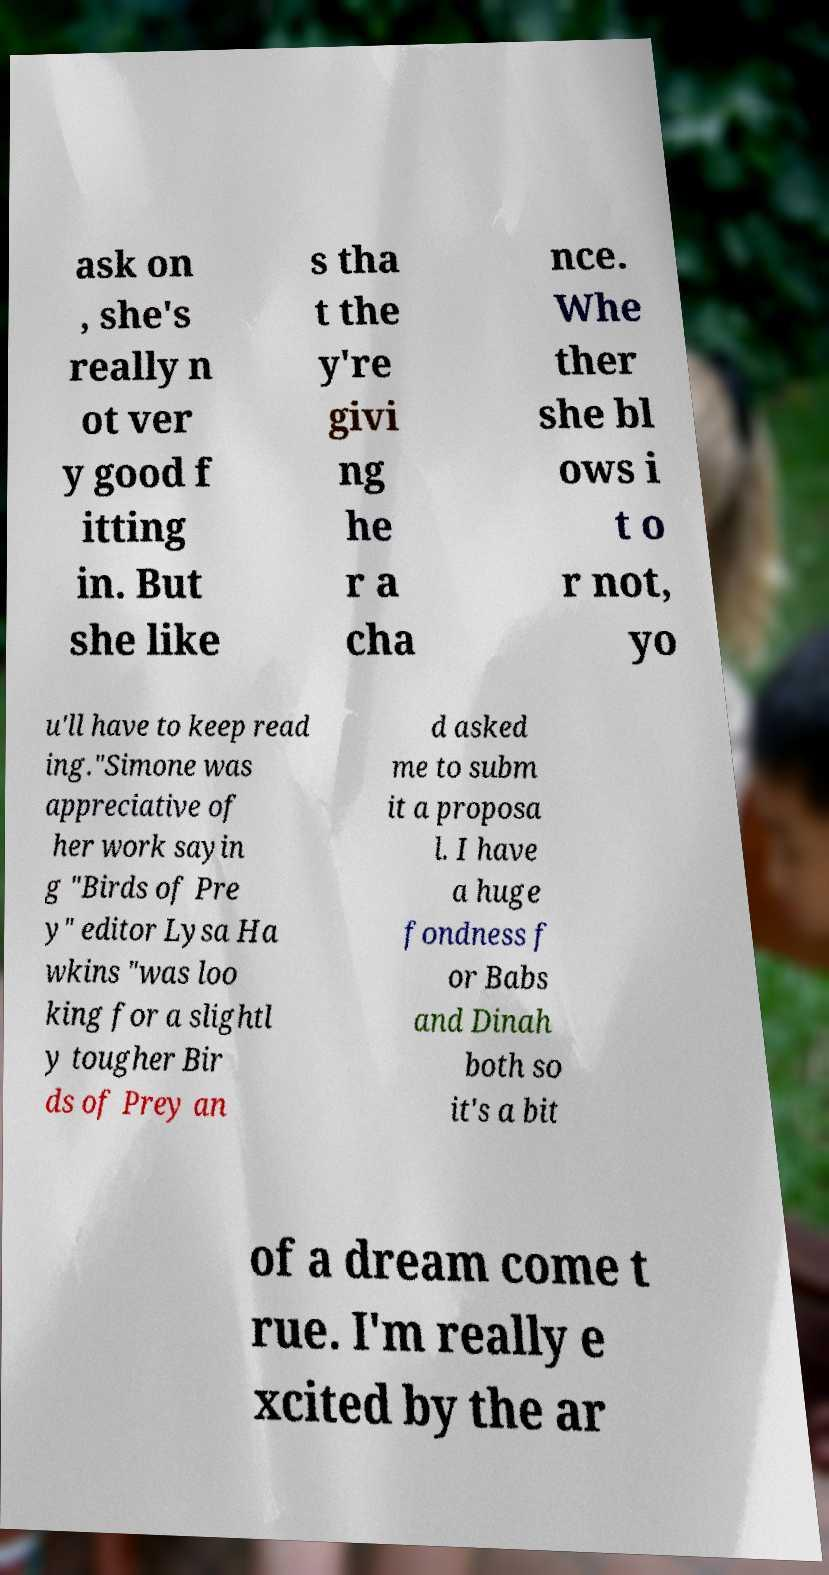For documentation purposes, I need the text within this image transcribed. Could you provide that? ask on , she's really n ot ver y good f itting in. But she like s tha t the y're givi ng he r a cha nce. Whe ther she bl ows i t o r not, yo u'll have to keep read ing."Simone was appreciative of her work sayin g "Birds of Pre y" editor Lysa Ha wkins "was loo king for a slightl y tougher Bir ds of Prey an d asked me to subm it a proposa l. I have a huge fondness f or Babs and Dinah both so it's a bit of a dream come t rue. I'm really e xcited by the ar 